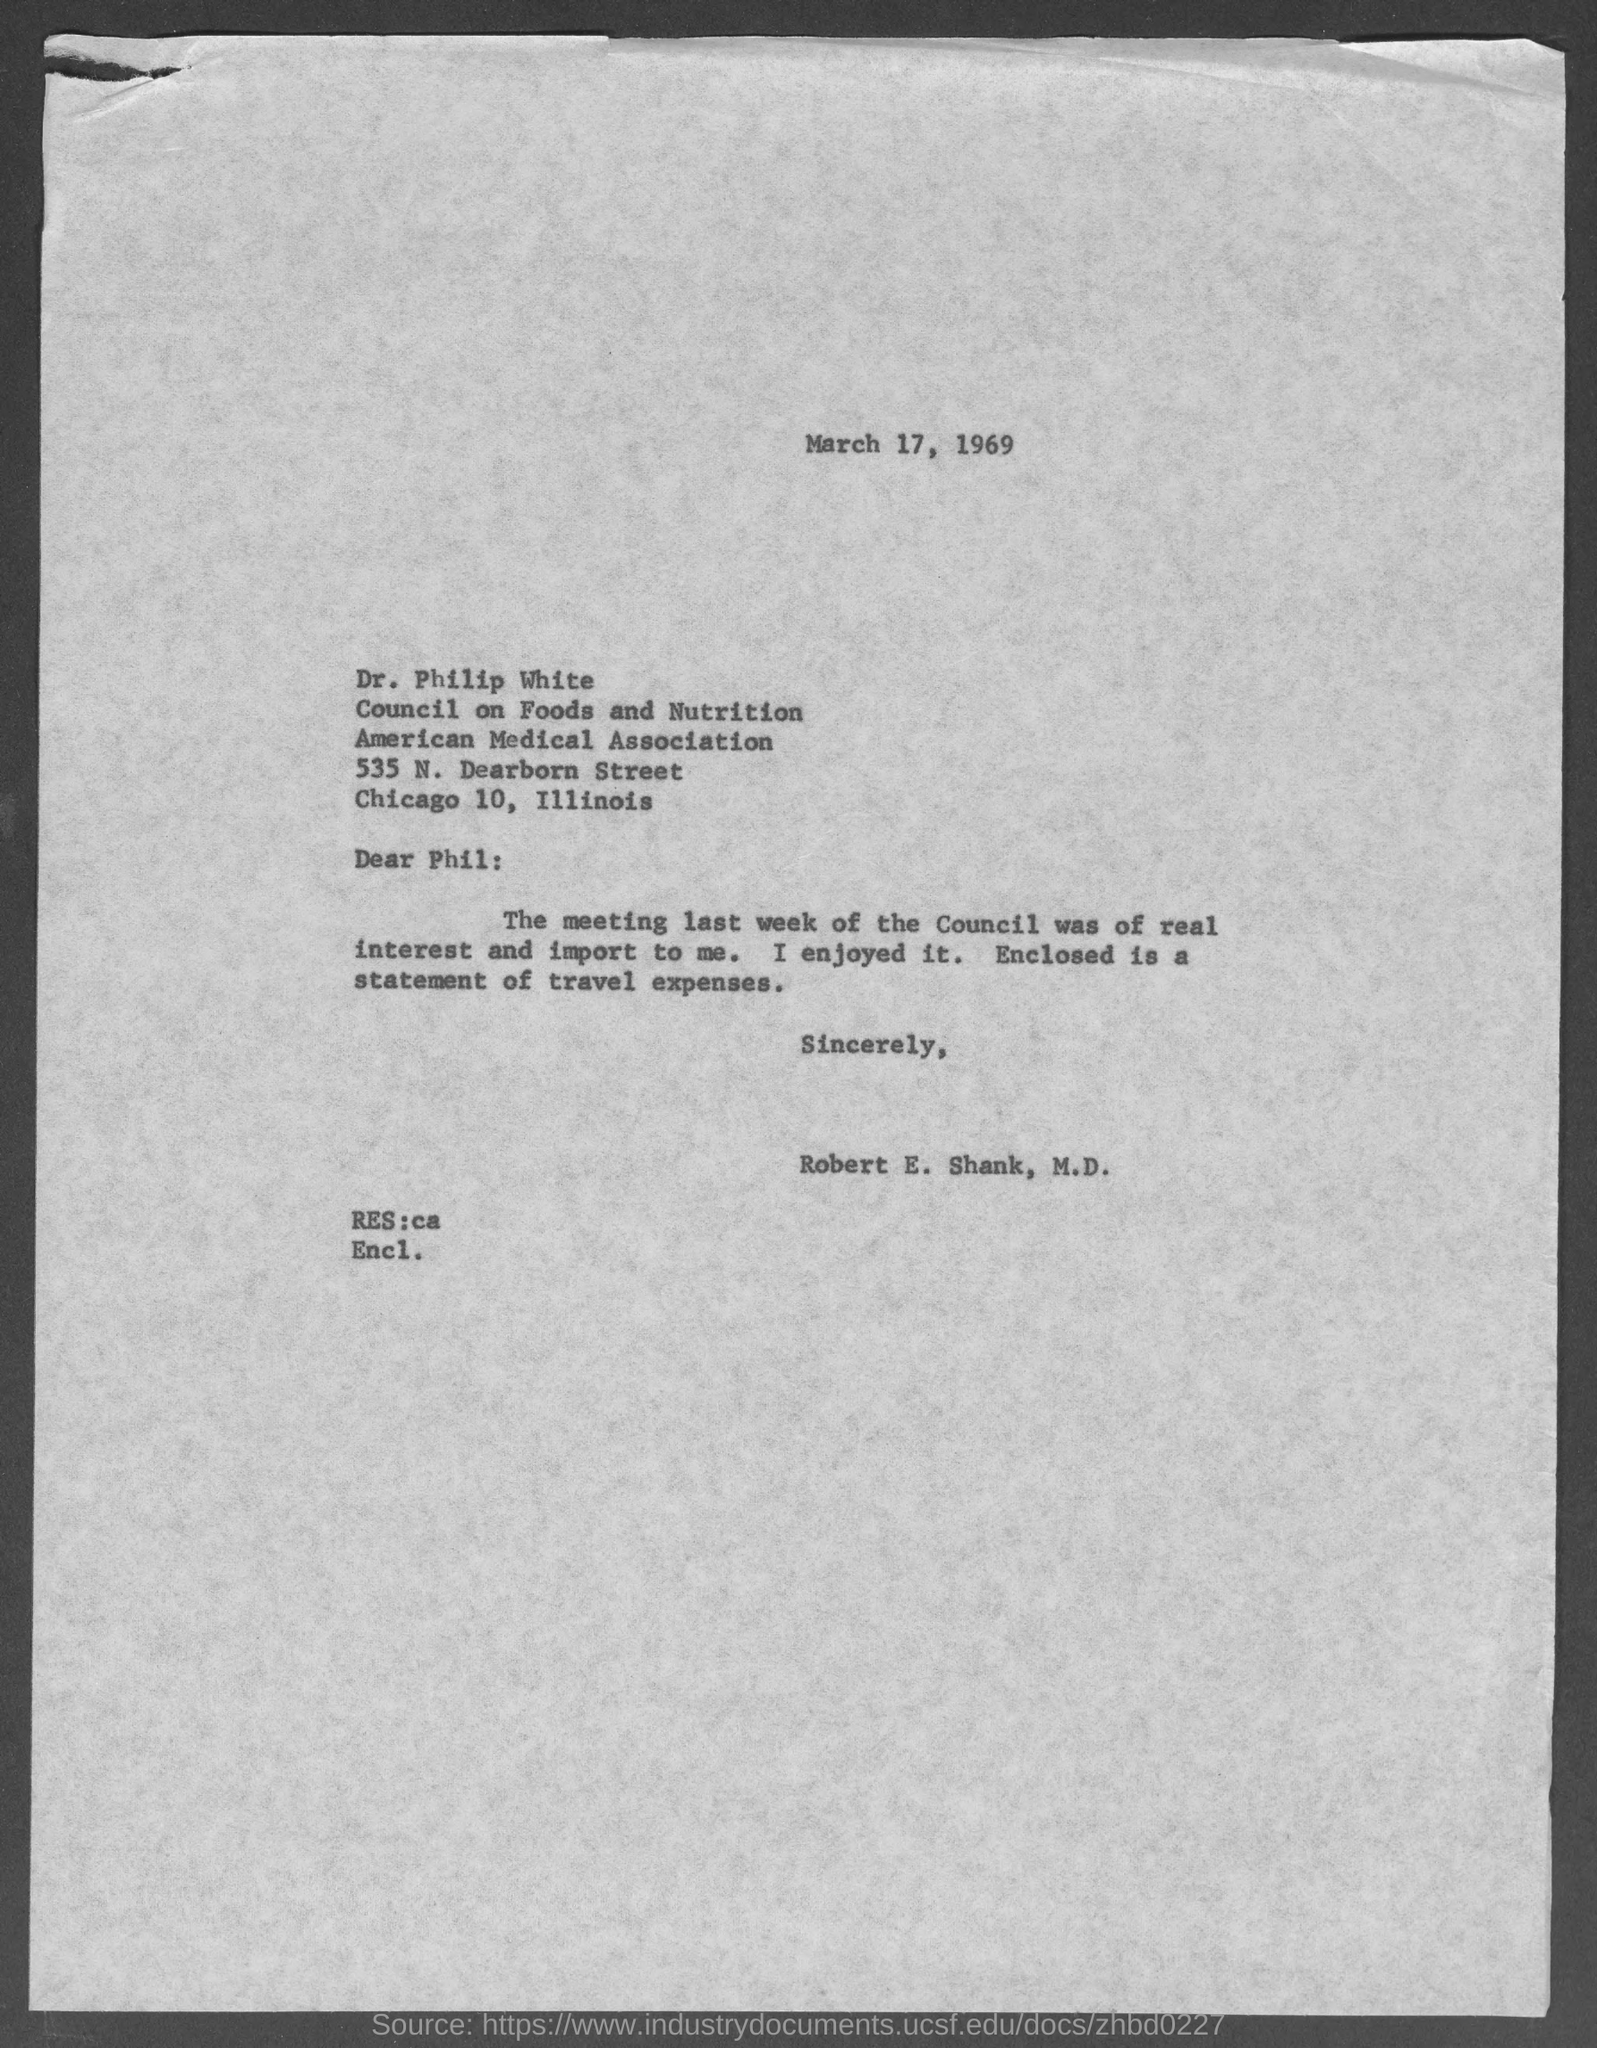Give some essential details in this illustration. The letter is dated March 17, 1969. The American Medical Association is located in Chicago, a city in the United States. The letter was written by Robert E. Shank, M.D. 